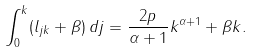Convert formula to latex. <formula><loc_0><loc_0><loc_500><loc_500>\int _ { 0 } ^ { k } ( l _ { j k } + \beta ) \, d j = \frac { 2 p } { \alpha + 1 } k ^ { \alpha + 1 } + \beta k .</formula> 